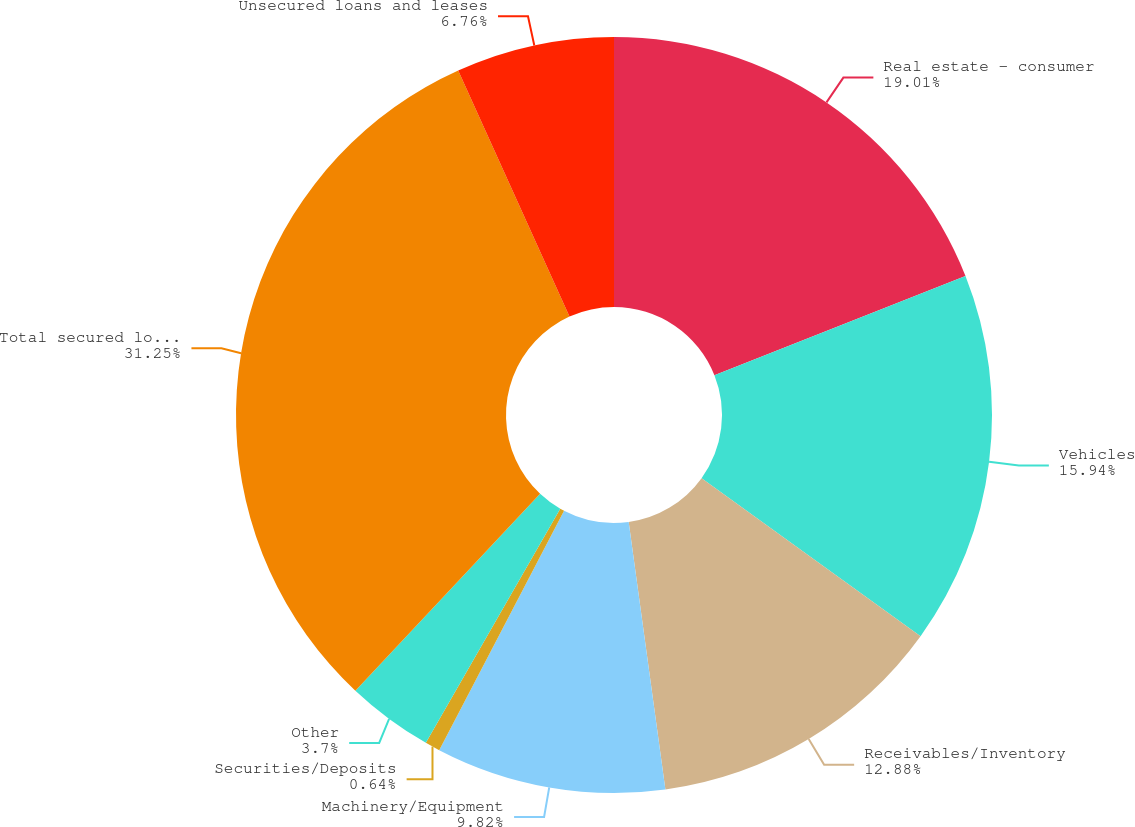<chart> <loc_0><loc_0><loc_500><loc_500><pie_chart><fcel>Real estate - consumer<fcel>Vehicles<fcel>Receivables/Inventory<fcel>Machinery/Equipment<fcel>Securities/Deposits<fcel>Other<fcel>Total secured loans and leases<fcel>Unsecured loans and leases<nl><fcel>19.0%<fcel>15.94%<fcel>12.88%<fcel>9.82%<fcel>0.64%<fcel>3.7%<fcel>31.24%<fcel>6.76%<nl></chart> 